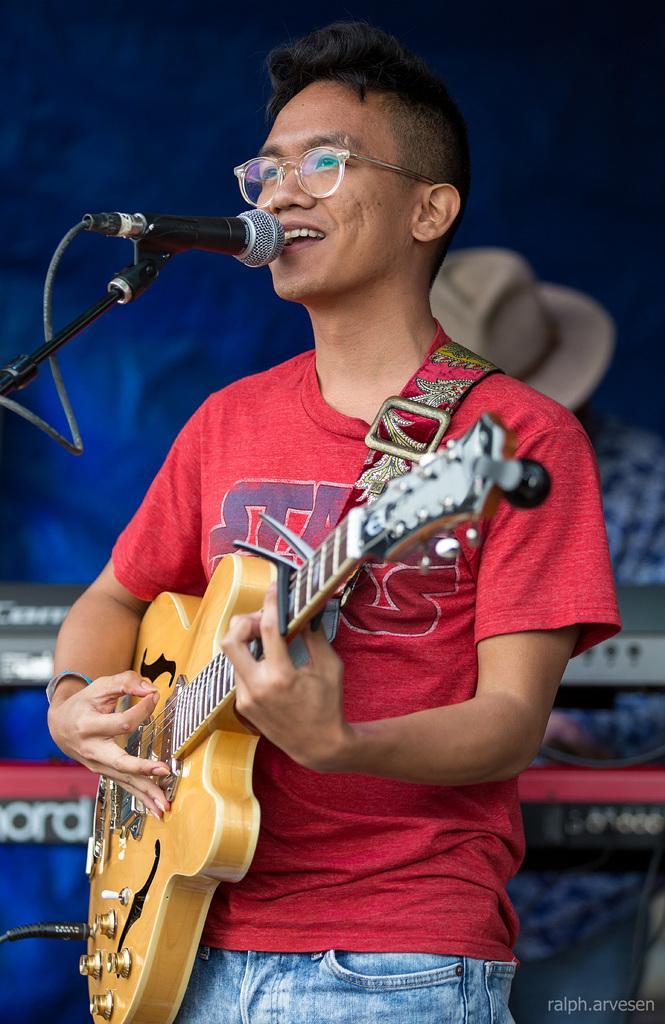Describe this image in one or two sentences. There is a person standing in the center. He is holding a guitar in his hand. He is playing a guitar and singing on a microphone. 